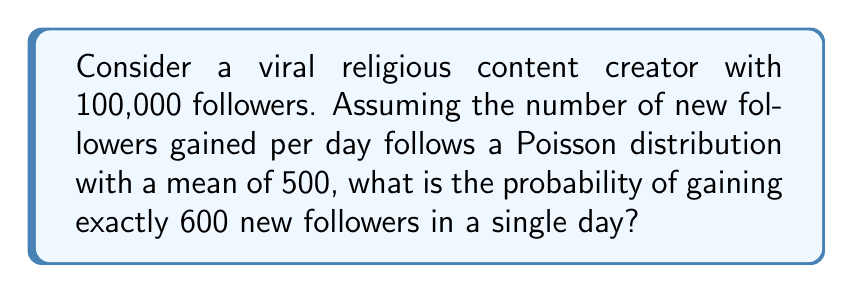Teach me how to tackle this problem. To solve this problem, we'll use the Poisson distribution formula:

$$P(X = k) = \frac{e^{-\lambda} \lambda^k}{k!}$$

Where:
$\lambda$ = mean number of events (new followers) per day
$k$ = number of events we're calculating the probability for
$e$ = Euler's number (approximately 2.71828)

Given:
$\lambda = 500$
$k = 600$

Step 1: Substitute the values into the formula:

$$P(X = 600) = \frac{e^{-500} 500^{600}}{600!}$$

Step 2: Calculate using a scientific calculator or computer program:

$$P(X = 600) \approx 0.001079$$

Step 3: Convert to percentage:

$$0.001079 \times 100\% \approx 0.1079\%$$
Answer: $0.1079\%$ 